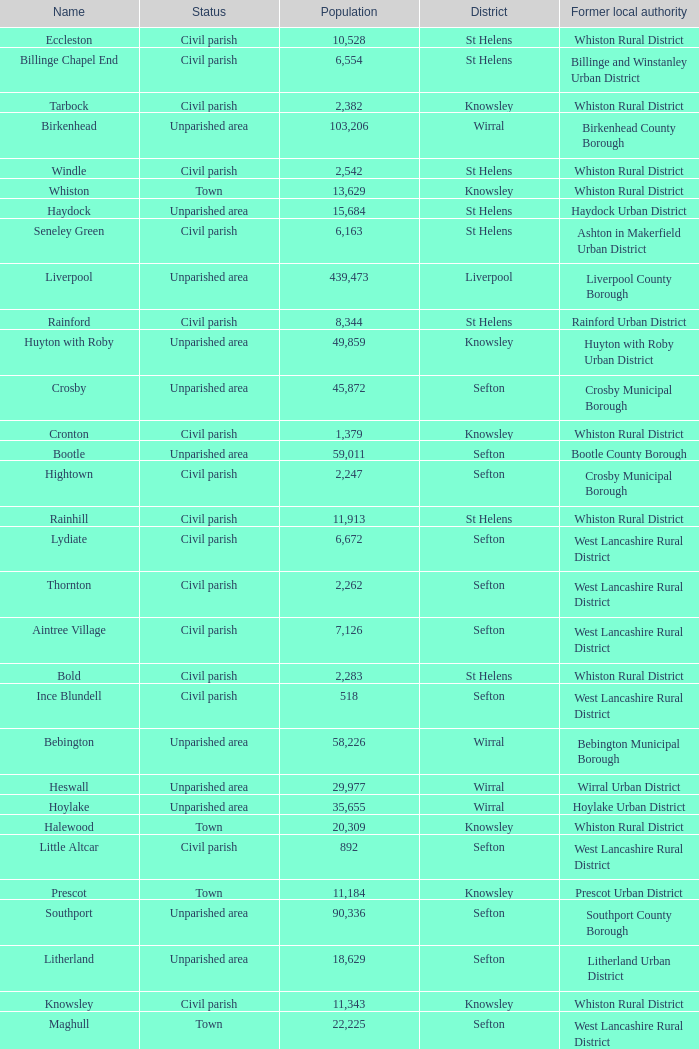What is the district of wallasey Wirral. 